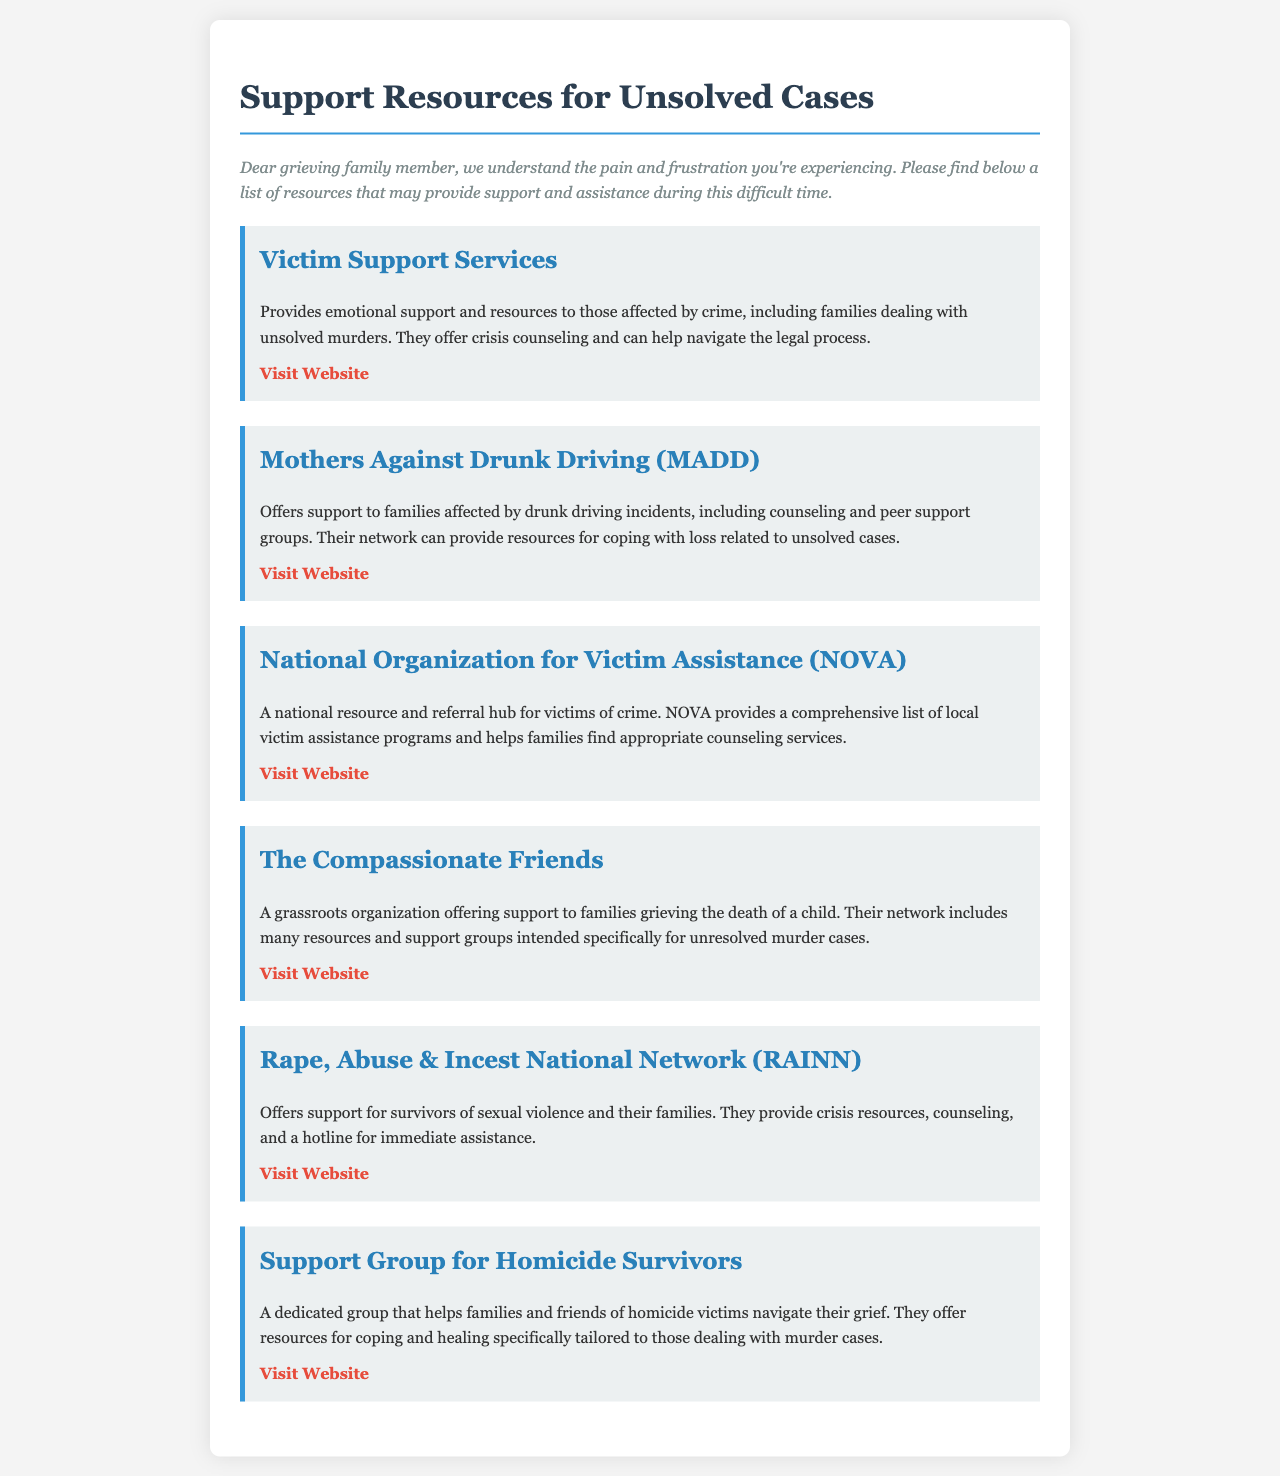what is the title of the document? The title is mentioned at the beginning of the document, indicating the main theme or purpose.
Answer: Support Resources for Unsolved Cases how many victim support services are listed? The document contains several sections, each representing a different service. Count them to find the total.
Answer: Six what organization offers support for families affected by drunk driving? The name of the organization that specifically offers this type of support is highlighted in its section.
Answer: Mothers Against Drunk Driving (MADD) which organization provides resources for families grieving the death of a child? This specific organization is mentioned in the context of supporting families dealing with unresolved cases of children's deaths.
Answer: The Compassionate Friends what type of support does the National Organization for Victim Assistance provide? The functions of this organization are described, focusing on its role in assisting victims of crime and connecting them with resources.
Answer: Referral hub how can families affected by homicide access support? The document lists a specific group dedicated to helping families cope with homicide.
Answer: Support Group for Homicide Survivors what is the website for Victim Support Services? Each resource section includes a hyperlink for easy access, specifying the website for Victim Support Services.
Answer: www.victimsupport.org what kind of group does RAINN serve? RAINN is focused on a specific demographic impacted by certain types of violence, which the document mentions.
Answer: Survivors of sexual violence what color is used for the section titles in the document? Describing the color used for section titles can help identify the visual design elements.
Answer: Blue 